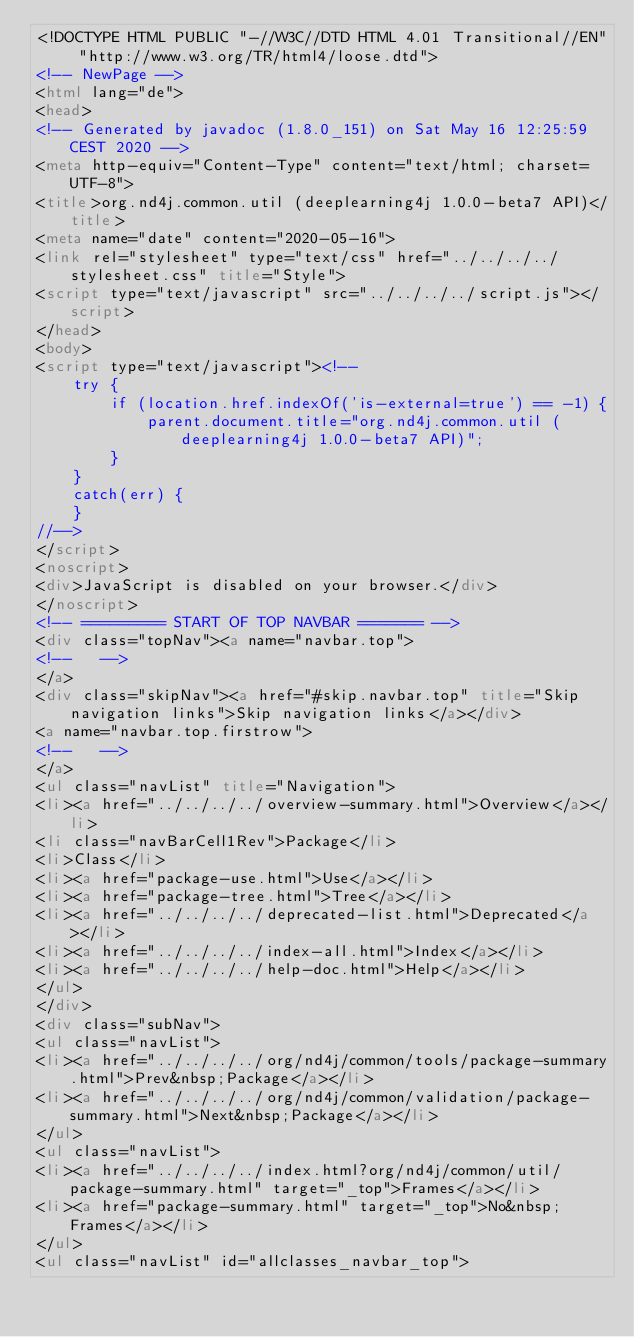Convert code to text. <code><loc_0><loc_0><loc_500><loc_500><_HTML_><!DOCTYPE HTML PUBLIC "-//W3C//DTD HTML 4.01 Transitional//EN" "http://www.w3.org/TR/html4/loose.dtd">
<!-- NewPage -->
<html lang="de">
<head>
<!-- Generated by javadoc (1.8.0_151) on Sat May 16 12:25:59 CEST 2020 -->
<meta http-equiv="Content-Type" content="text/html; charset=UTF-8">
<title>org.nd4j.common.util (deeplearning4j 1.0.0-beta7 API)</title>
<meta name="date" content="2020-05-16">
<link rel="stylesheet" type="text/css" href="../../../../stylesheet.css" title="Style">
<script type="text/javascript" src="../../../../script.js"></script>
</head>
<body>
<script type="text/javascript"><!--
    try {
        if (location.href.indexOf('is-external=true') == -1) {
            parent.document.title="org.nd4j.common.util (deeplearning4j 1.0.0-beta7 API)";
        }
    }
    catch(err) {
    }
//-->
</script>
<noscript>
<div>JavaScript is disabled on your browser.</div>
</noscript>
<!-- ========= START OF TOP NAVBAR ======= -->
<div class="topNav"><a name="navbar.top">
<!--   -->
</a>
<div class="skipNav"><a href="#skip.navbar.top" title="Skip navigation links">Skip navigation links</a></div>
<a name="navbar.top.firstrow">
<!--   -->
</a>
<ul class="navList" title="Navigation">
<li><a href="../../../../overview-summary.html">Overview</a></li>
<li class="navBarCell1Rev">Package</li>
<li>Class</li>
<li><a href="package-use.html">Use</a></li>
<li><a href="package-tree.html">Tree</a></li>
<li><a href="../../../../deprecated-list.html">Deprecated</a></li>
<li><a href="../../../../index-all.html">Index</a></li>
<li><a href="../../../../help-doc.html">Help</a></li>
</ul>
</div>
<div class="subNav">
<ul class="navList">
<li><a href="../../../../org/nd4j/common/tools/package-summary.html">Prev&nbsp;Package</a></li>
<li><a href="../../../../org/nd4j/common/validation/package-summary.html">Next&nbsp;Package</a></li>
</ul>
<ul class="navList">
<li><a href="../../../../index.html?org/nd4j/common/util/package-summary.html" target="_top">Frames</a></li>
<li><a href="package-summary.html" target="_top">No&nbsp;Frames</a></li>
</ul>
<ul class="navList" id="allclasses_navbar_top"></code> 